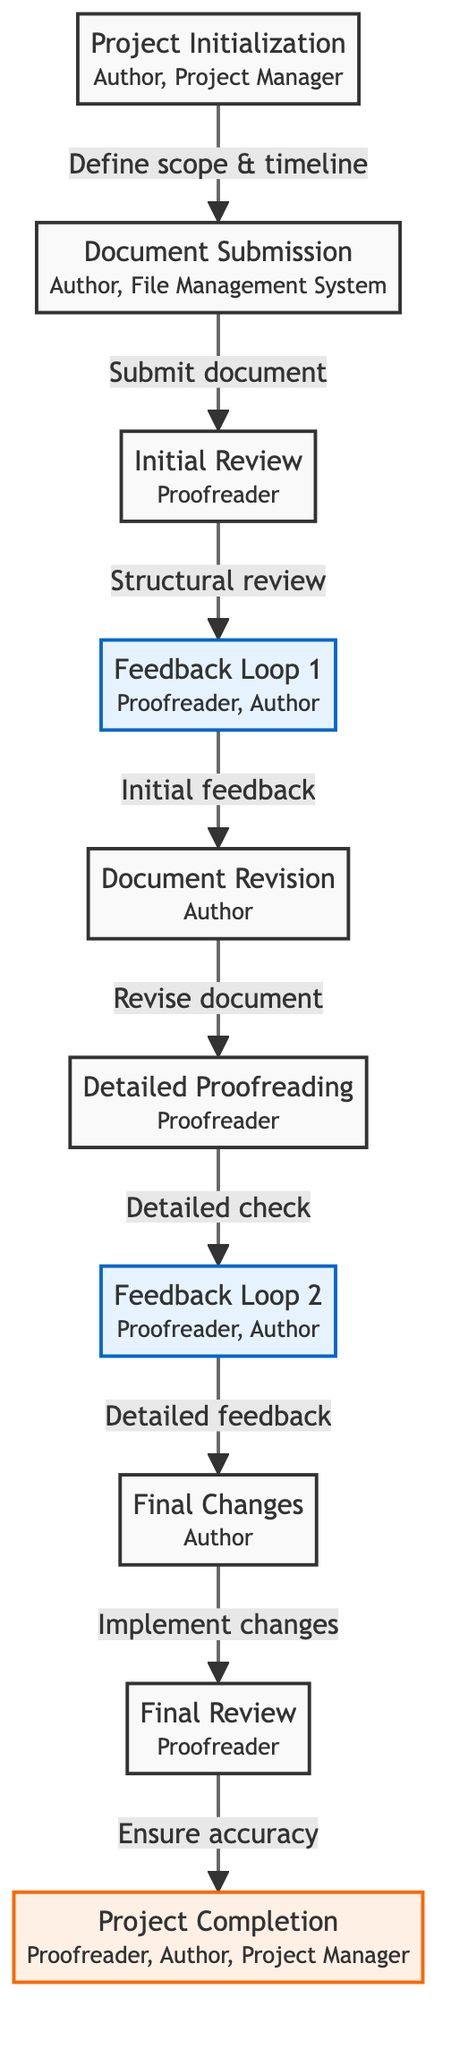What is the first step in the proofreading project? The diagram shows "Project Initialization" as the first node in the workflow, indicating it is the first step where the scope, objectives, and timeline are defined.
Answer: Project Initialization Who are the stakeholders involved in the Initial Review? Looking at the "Initial Review" node, it is clear that the only stakeholder mentioned there is the Proofreader.
Answer: Proofreader How many feedback loops are present in the diagram? The diagram lists two feedback loops: "Feedback Loop 1" and "Feedback Loop 2," indicating there are two distinct points where feedback is provided.
Answer: 2 What follows the Document Revision step? Following the "Document Revision" step in the workflow, the next step is "Detailed Proofreading," where the proofreader conducts detailed checks.
Answer: Detailed Proofreading Which stakeholder makes final changes based on feedback? The "Final Changes" section indicates that these changes are made by the Author, as stated in the description of that node.
Answer: Author What type of checks are done in the Detailed Proofreading step? The "Detailed Proofreading" node describes that this step involves grammar, punctuation, and style checks, which are the specific checks performed at this stage.
Answer: Grammar, punctuation, and style checks What is included in the final stage of the project? The "Project Completion" node explains that it is the culmination of the document being finalized and ready for publishing or submission, which is the main content of this step.
Answer: Document finalized and ready for publishing What is the direction of the transition from Initial Review to Feedback Loop 1? The transition from "Initial Review" to "Feedback Loop 1" is indicated by an arrow, showing that the flow moves from conducting a structural review to providing initial feedback to the author.
Answer: Initial feedback Who are the stakeholders in the Project Completion step? In the "Project Completion" section, the stakeholders listed are the Proofreader, Author, and Project Manager, indicating the collaborative nature of this final step.
Answer: Proofreader, Author, Project Manager 